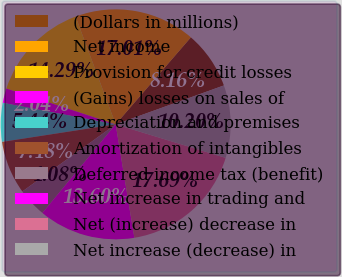Convert chart. <chart><loc_0><loc_0><loc_500><loc_500><pie_chart><fcel>(Dollars in millions)<fcel>Net income<fcel>Provision for credit losses<fcel>(Gains) losses on sales of<fcel>Depreciation and premises<fcel>Amortization of intangibles<fcel>Deferred income tax (benefit)<fcel>Net increase in trading and<fcel>Net (increase) decrease in<fcel>Net increase (decrease) in<nl><fcel>8.16%<fcel>17.01%<fcel>14.29%<fcel>2.04%<fcel>5.44%<fcel>7.48%<fcel>4.08%<fcel>13.6%<fcel>17.69%<fcel>10.2%<nl></chart> 